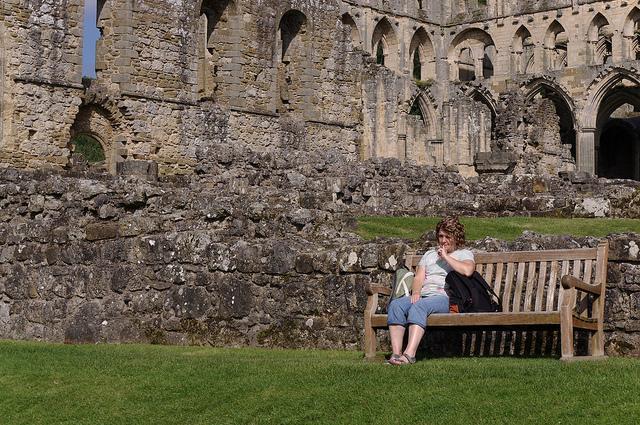How many people are there?
Give a very brief answer. 1. 